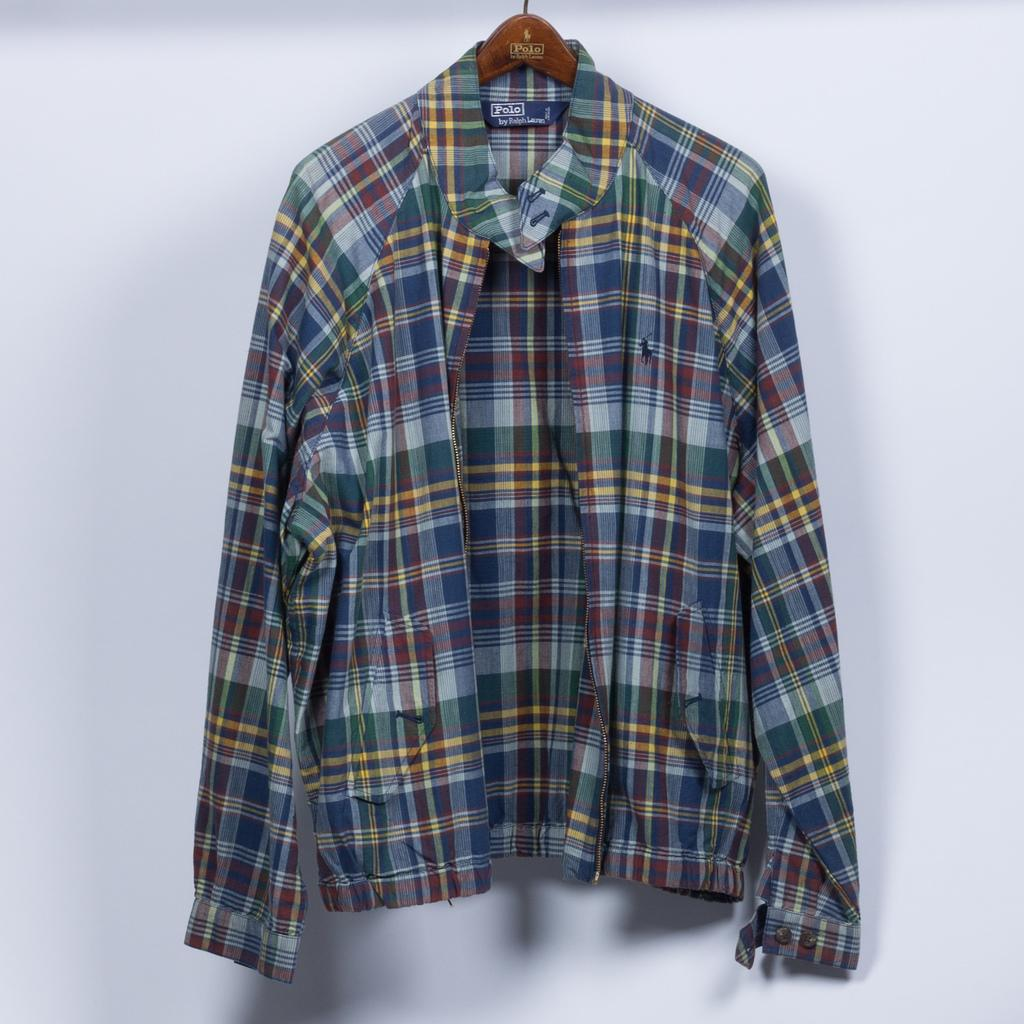What type of clothing item is in the image? There is a shirt in the image. How is the shirt positioned in the image? The shirt is hanged on a hanger. What color is the background in the image? The background is white. Where is the library located in the image? There is no library present in the image. What type of carriage is visible in the image? There is no carriage present in the image. 